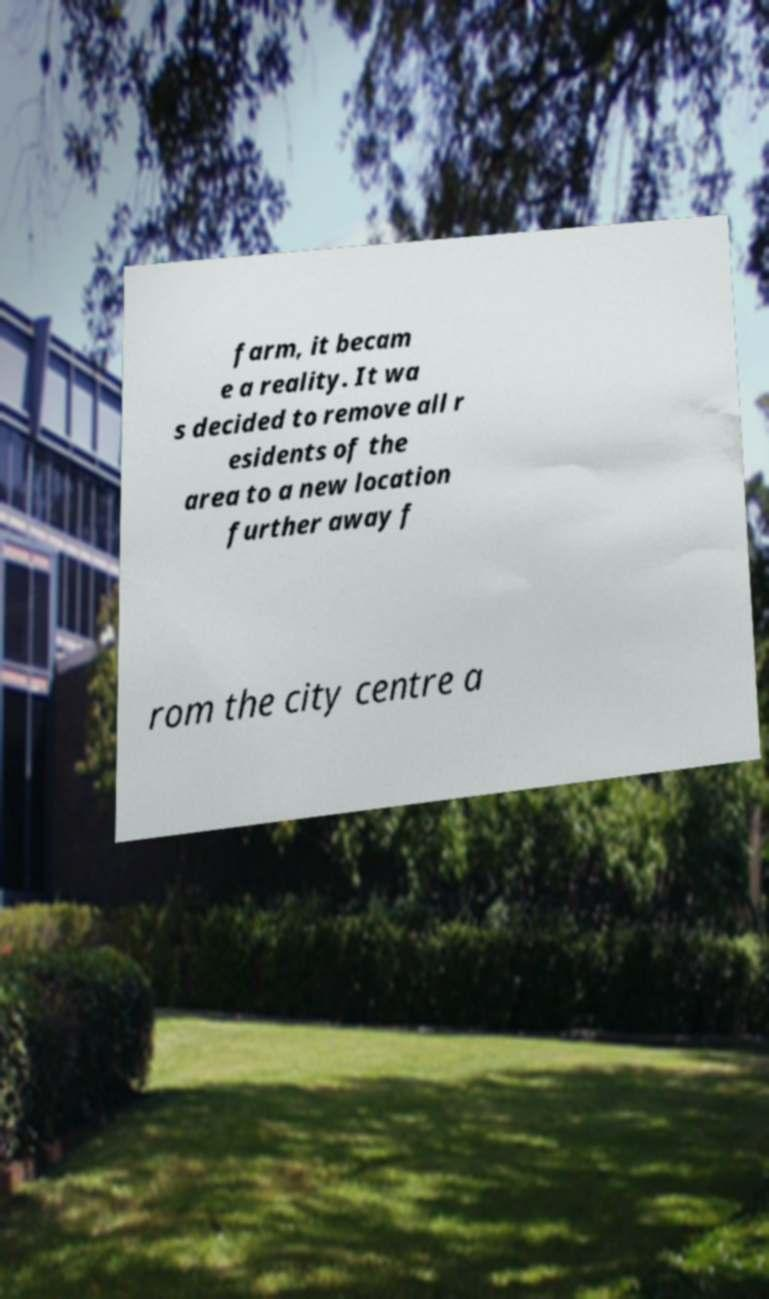Could you extract and type out the text from this image? farm, it becam e a reality. It wa s decided to remove all r esidents of the area to a new location further away f rom the city centre a 